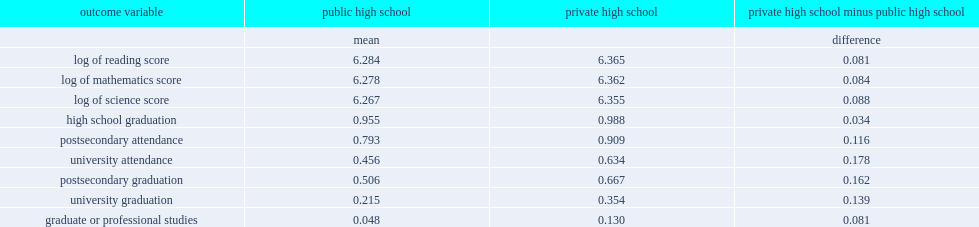In the reading test, how many log points did private school students outperform their public school counterparts? 0.081. By age 23, what was the percent of private school students had graduated from high school? 0.988. By age 23, 99% of private school students had graduated from high school, how many percentage points above the figure for public school students? 0.033. 